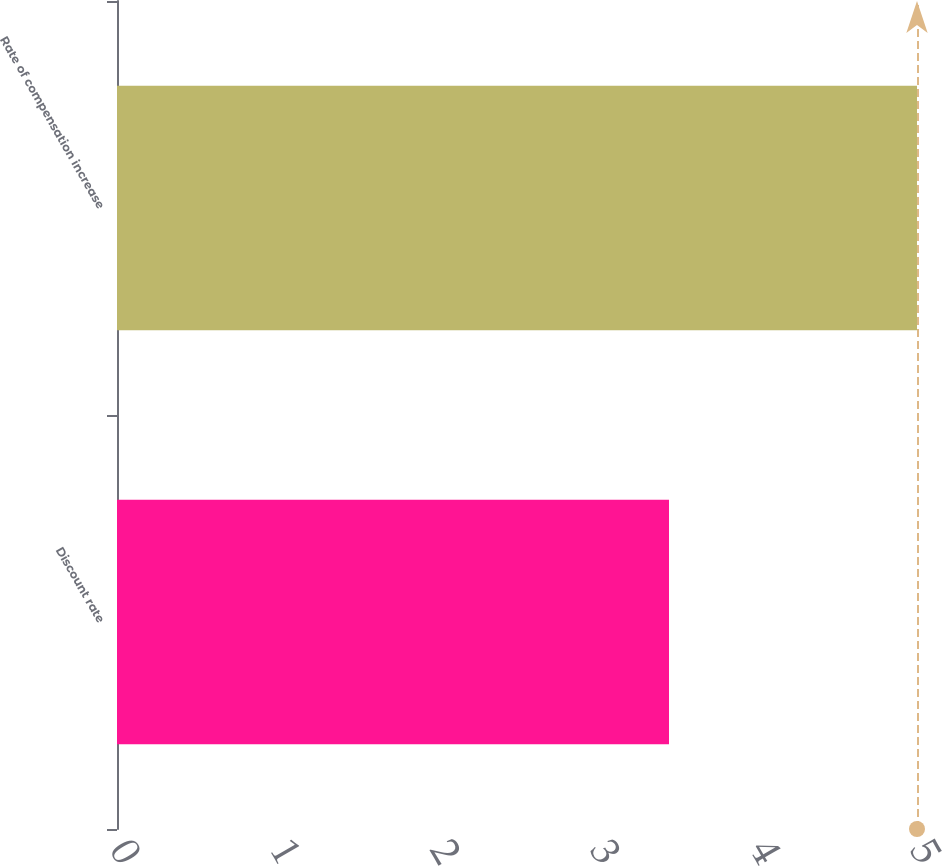Convert chart to OTSL. <chart><loc_0><loc_0><loc_500><loc_500><bar_chart><fcel>Discount rate<fcel>Rate of compensation increase<nl><fcel>3.45<fcel>5<nl></chart> 